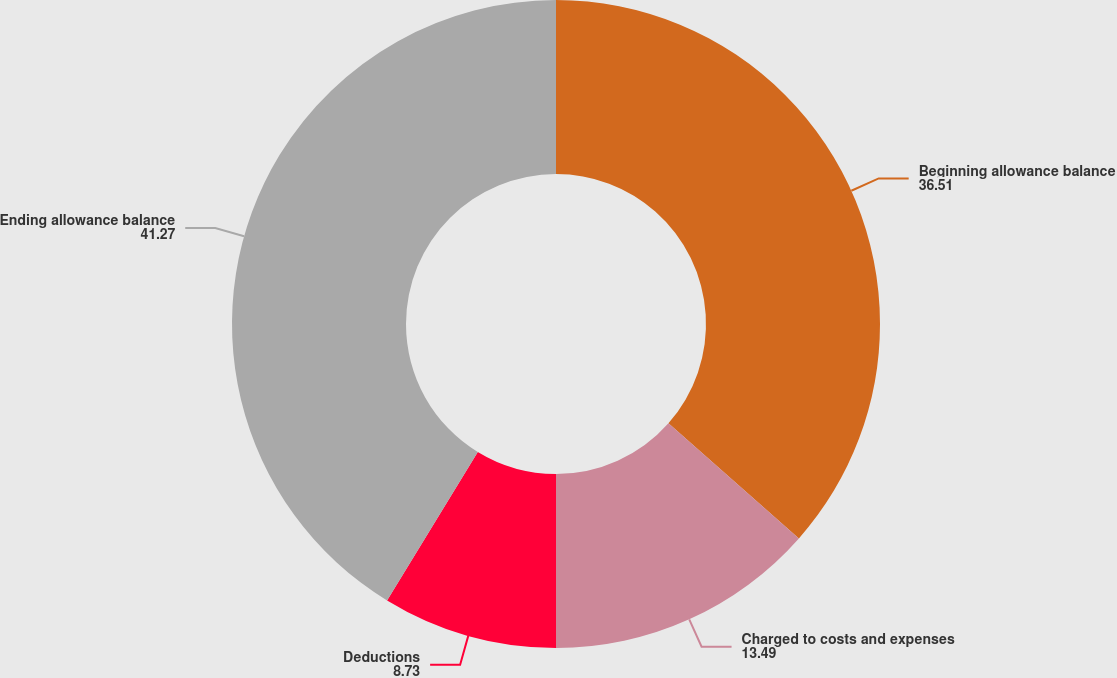Convert chart. <chart><loc_0><loc_0><loc_500><loc_500><pie_chart><fcel>Beginning allowance balance<fcel>Charged to costs and expenses<fcel>Deductions<fcel>Ending allowance balance<nl><fcel>36.51%<fcel>13.49%<fcel>8.73%<fcel>41.27%<nl></chart> 